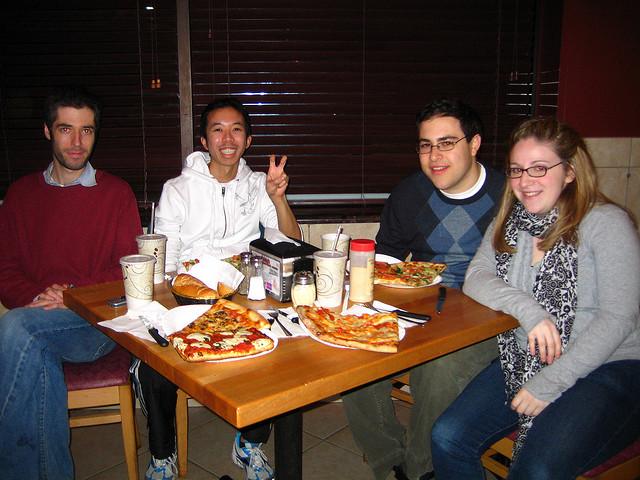How many people are seated?
Quick response, please. 4. How many fingers is the male in white holding up?
Be succinct. 2. What kind of pants are they wearing?
Be succinct. Jeans. How many people are in the photo?
Keep it brief. 4. Are the people having dinner?
Concise answer only. Yes. Was alcohol served with the meal?
Concise answer only. No. What type of food is this?
Give a very brief answer. Pizza. What are the people eating?
Answer briefly. Pizza. Is this a celebration?
Concise answer only. Yes. What color are the cups?
Be succinct. White. Are these young people?
Quick response, please. Yes. How many people are wearing plaid shirts?
Quick response, please. 0. Have the people sat down to eat?
Answer briefly. Yes. Are there more candies or pieces of fruit on the table?
Concise answer only. Neither. How many people are sitting?
Write a very short answer. 4. 